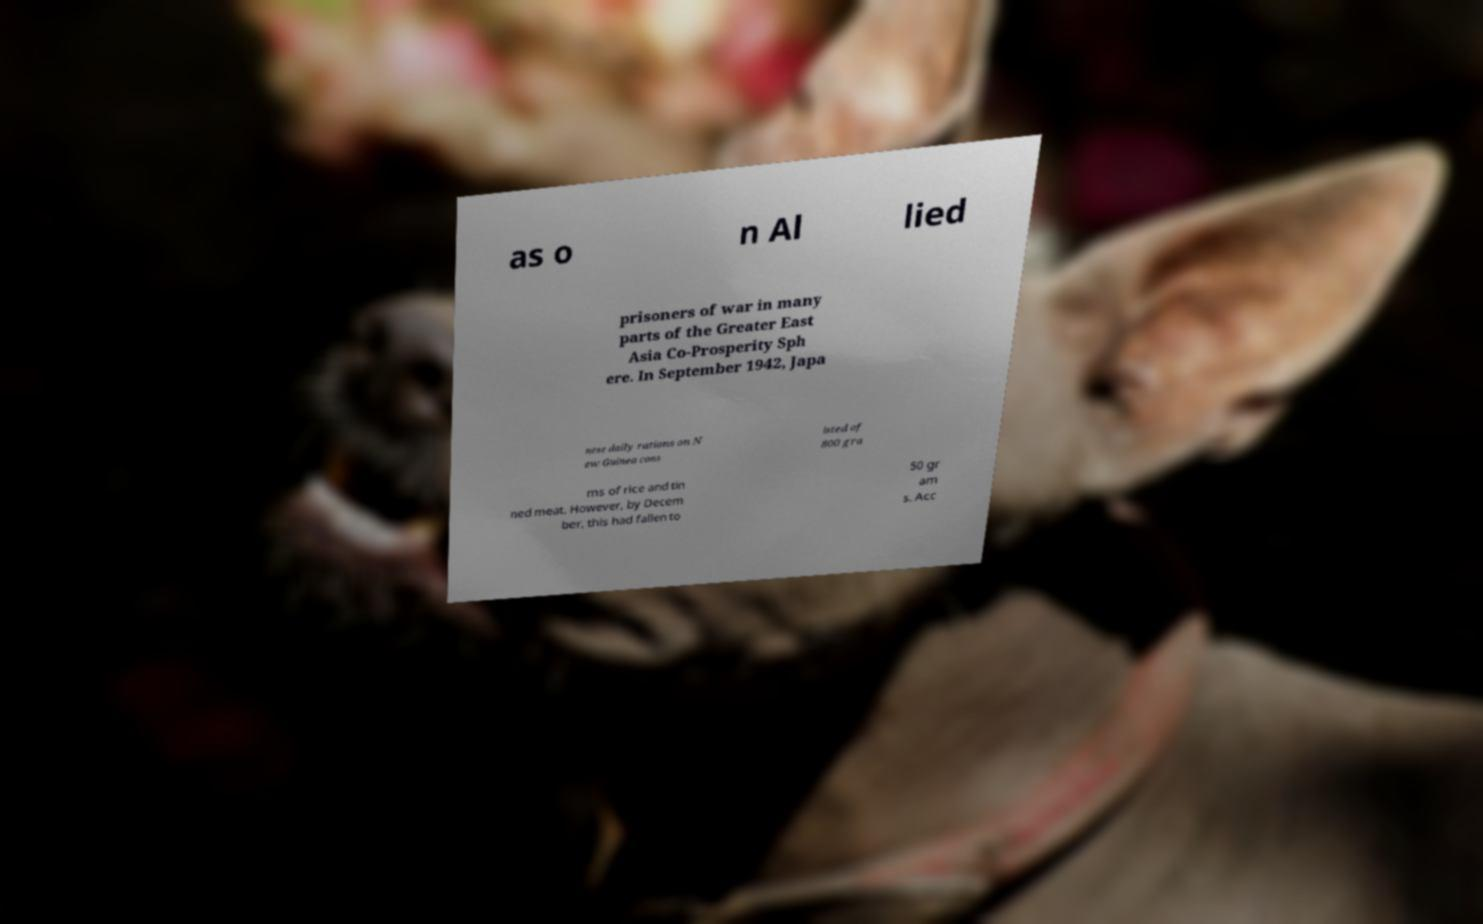What messages or text are displayed in this image? I need them in a readable, typed format. as o n Al lied prisoners of war in many parts of the Greater East Asia Co-Prosperity Sph ere. In September 1942, Japa nese daily rations on N ew Guinea cons isted of 800 gra ms of rice and tin ned meat. However, by Decem ber, this had fallen to 50 gr am s. Acc 